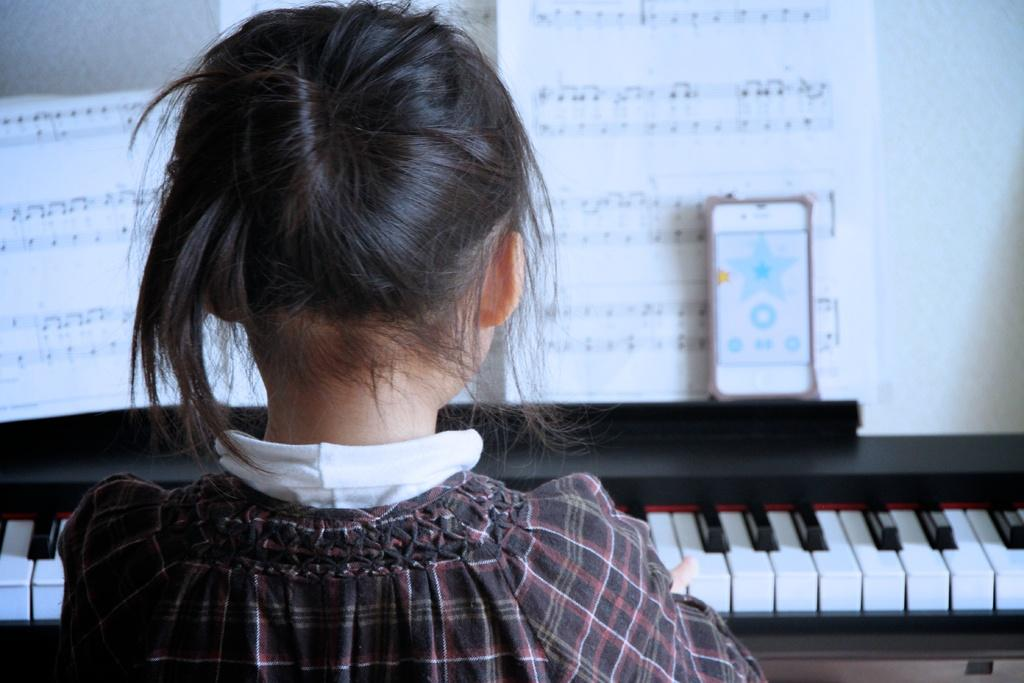Who is the main subject in the image? There is a girl in the image. What is the girl doing in the image? The girl is playing a piano. What can be seen in the background of the image? There is a paper and a wall in the background of the image. What type of apparatus is used to drain the rice in the image? There is no apparatus, rice, or draining activity present in the image. 